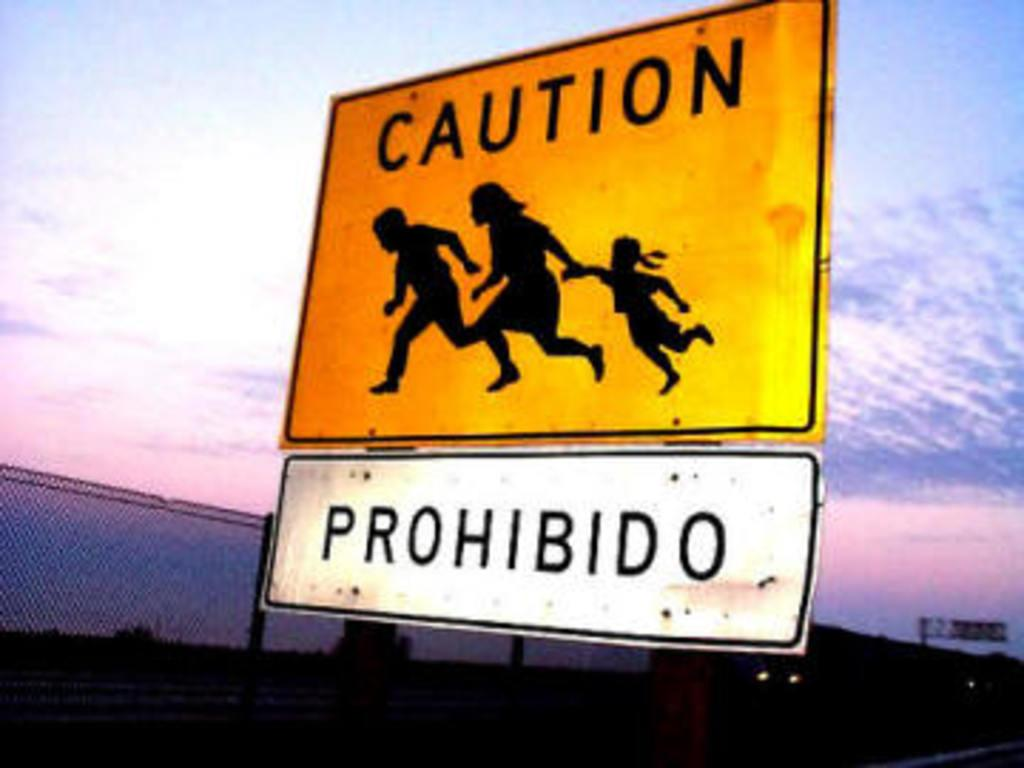<image>
Summarize the visual content of the image. A road sign partially in Spanish cautions families to be careful. 